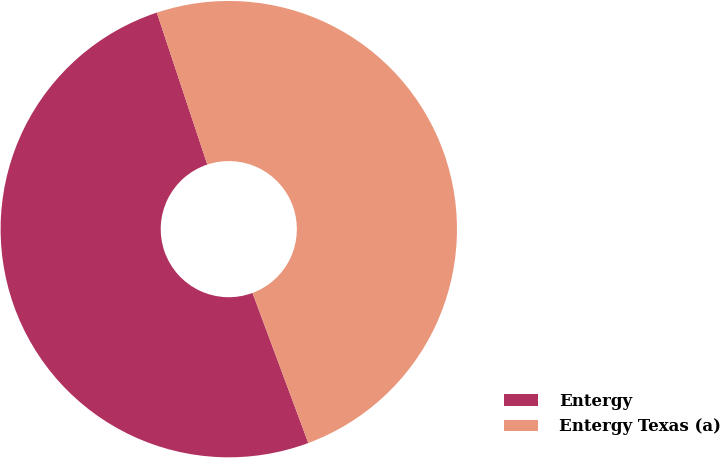Convert chart. <chart><loc_0><loc_0><loc_500><loc_500><pie_chart><fcel>Entergy<fcel>Entergy Texas (a)<nl><fcel>50.56%<fcel>49.44%<nl></chart> 